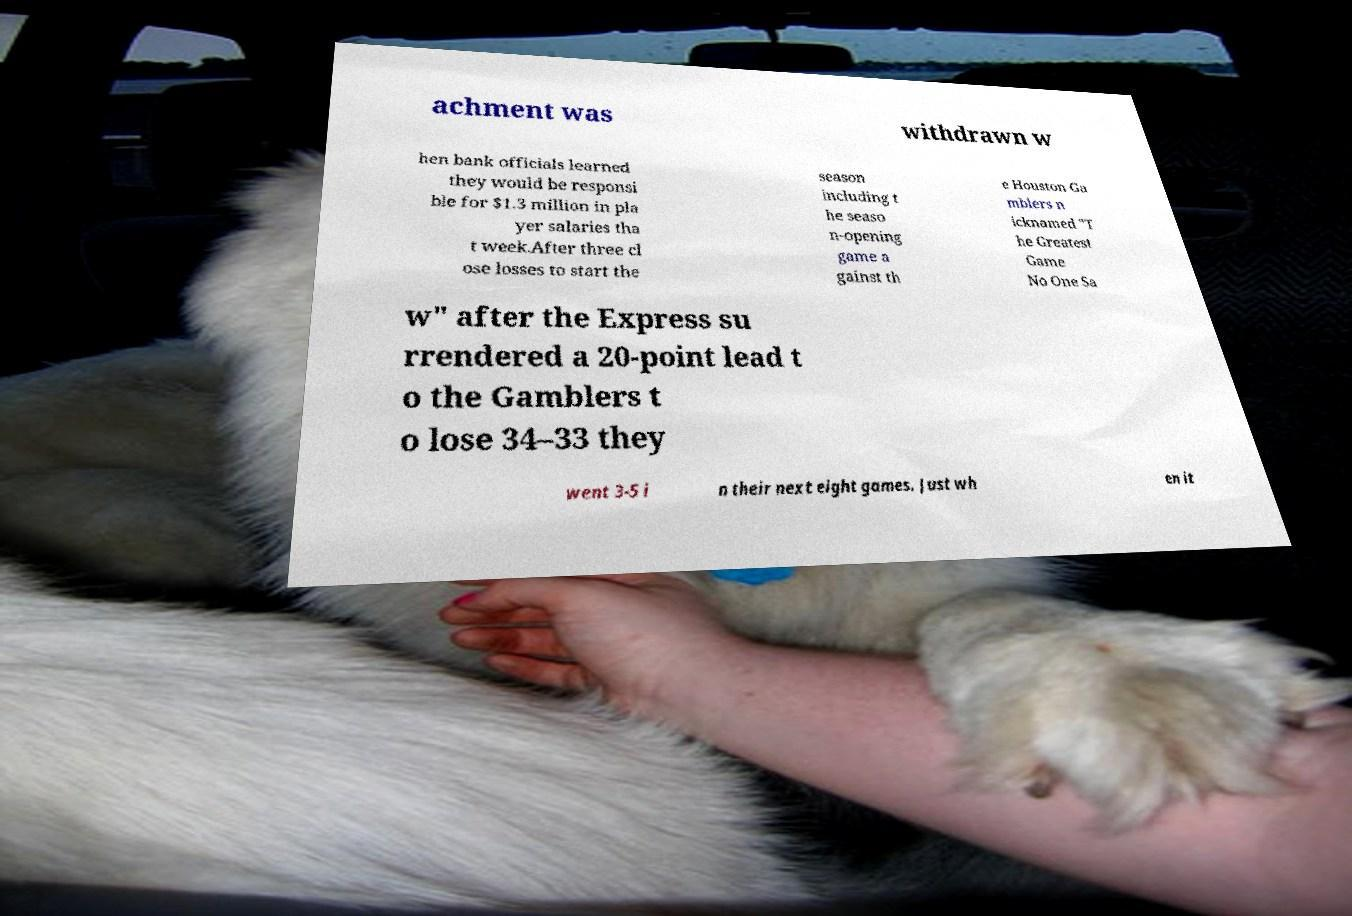Please identify and transcribe the text found in this image. achment was withdrawn w hen bank officials learned they would be responsi ble for $1.3 million in pla yer salaries tha t week.After three cl ose losses to start the season including t he seaso n-opening game a gainst th e Houston Ga mblers n icknamed "T he Greatest Game No One Sa w" after the Express su rrendered a 20-point lead t o the Gamblers t o lose 34–33 they went 3-5 i n their next eight games. Just wh en it 